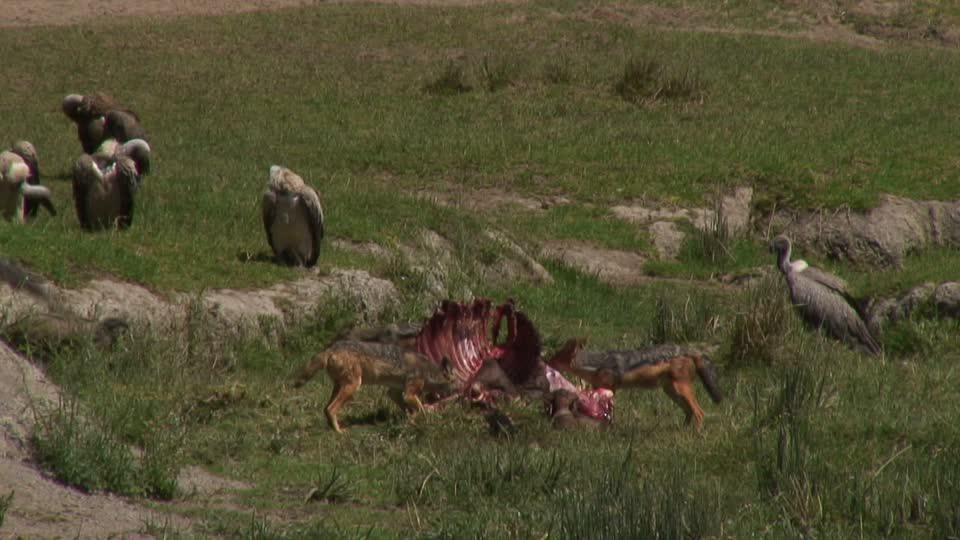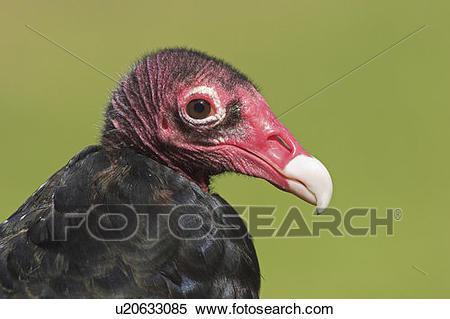The first image is the image on the left, the second image is the image on the right. For the images displayed, is the sentence "The left and right image contains the same number of vultures." factually correct? Answer yes or no. No. The first image is the image on the left, the second image is the image on the right. For the images shown, is this caption "The left image features one vulture with tucked wings, and the right image features one leftward-facing vulture with spread wings." true? Answer yes or no. No. 